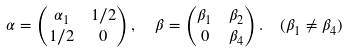<formula> <loc_0><loc_0><loc_500><loc_500>\alpha & = \begin{pmatrix} \alpha _ { 1 } & 1 / 2 \\ 1 / 2 & 0 \end{pmatrix} , \quad \beta = \begin{pmatrix} \beta _ { 1 } & \beta _ { 2 } \\ 0 & \beta _ { 4 } \end{pmatrix} . \quad ( \beta _ { 1 } \neq \beta _ { 4 } )</formula> 